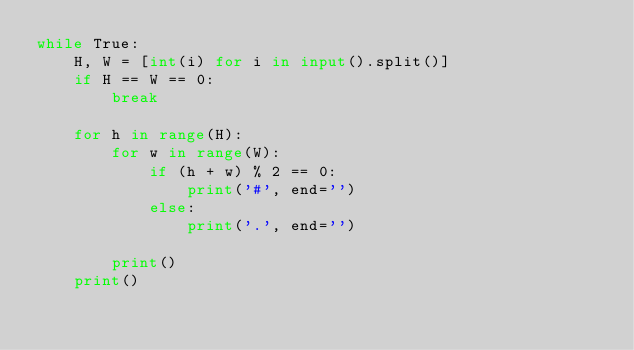Convert code to text. <code><loc_0><loc_0><loc_500><loc_500><_Python_>while True:
    H, W = [int(i) for i in input().split()]
    if H == W == 0:
        break

    for h in range(H):
        for w in range(W):
            if (h + w) % 2 == 0:
                print('#', end='')
            else:
                print('.', end='')

        print()
    print()</code> 